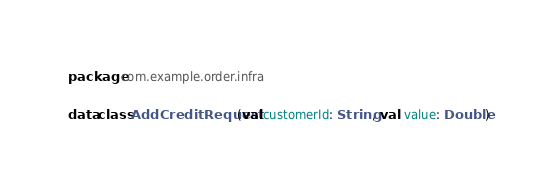Convert code to text. <code><loc_0><loc_0><loc_500><loc_500><_Kotlin_>package com.example.order.infra

data class AddCreditRequest(val customerId: String, val  value: Double)</code> 